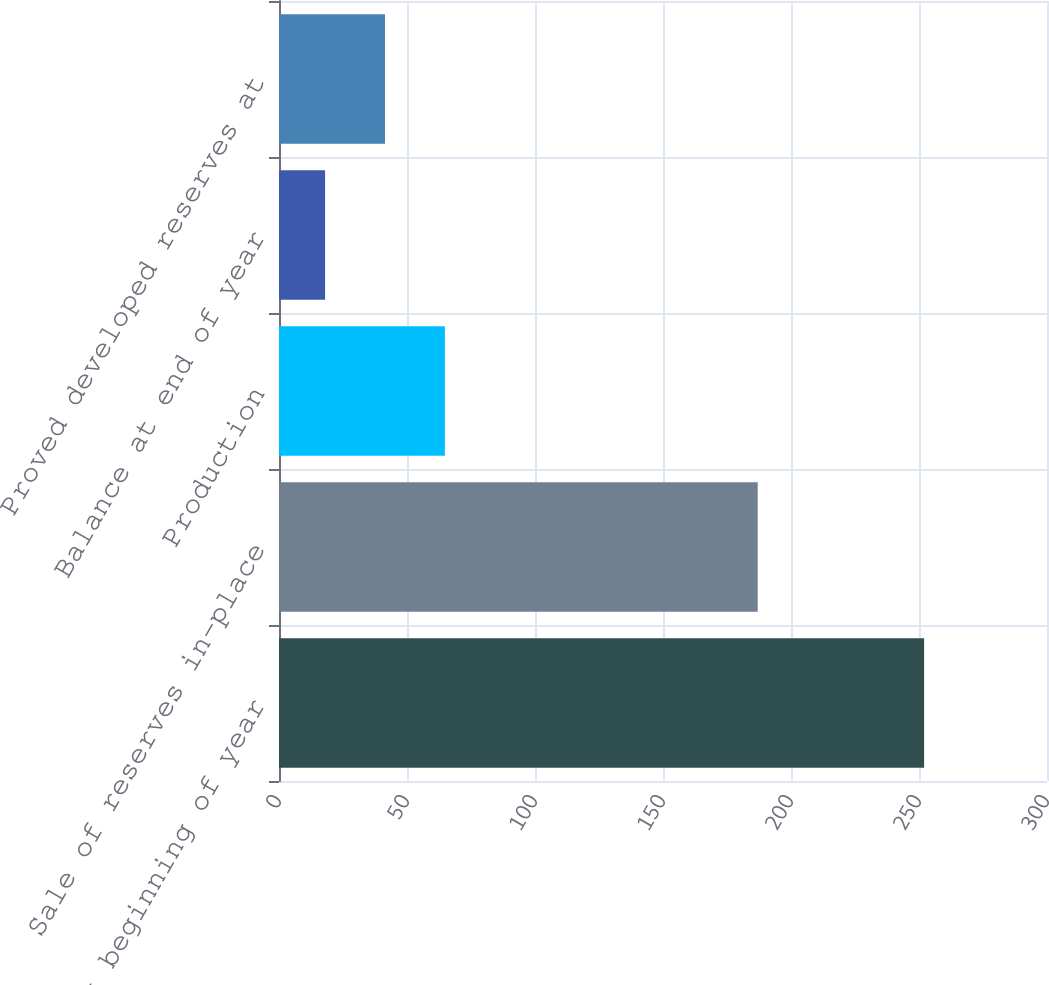Convert chart to OTSL. <chart><loc_0><loc_0><loc_500><loc_500><bar_chart><fcel>Balance at beginning of year<fcel>Sale of reserves in-place<fcel>Production<fcel>Balance at end of year<fcel>Proved developed reserves at<nl><fcel>252<fcel>187<fcel>64.8<fcel>18<fcel>41.4<nl></chart> 